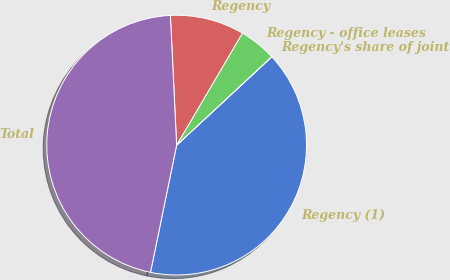Convert chart to OTSL. <chart><loc_0><loc_0><loc_500><loc_500><pie_chart><fcel>Regency (1)<fcel>Regency's share of joint<fcel>Regency - office leases<fcel>Regency<fcel>Total<nl><fcel>40.13%<fcel>0.02%<fcel>4.62%<fcel>9.22%<fcel>46.0%<nl></chart> 